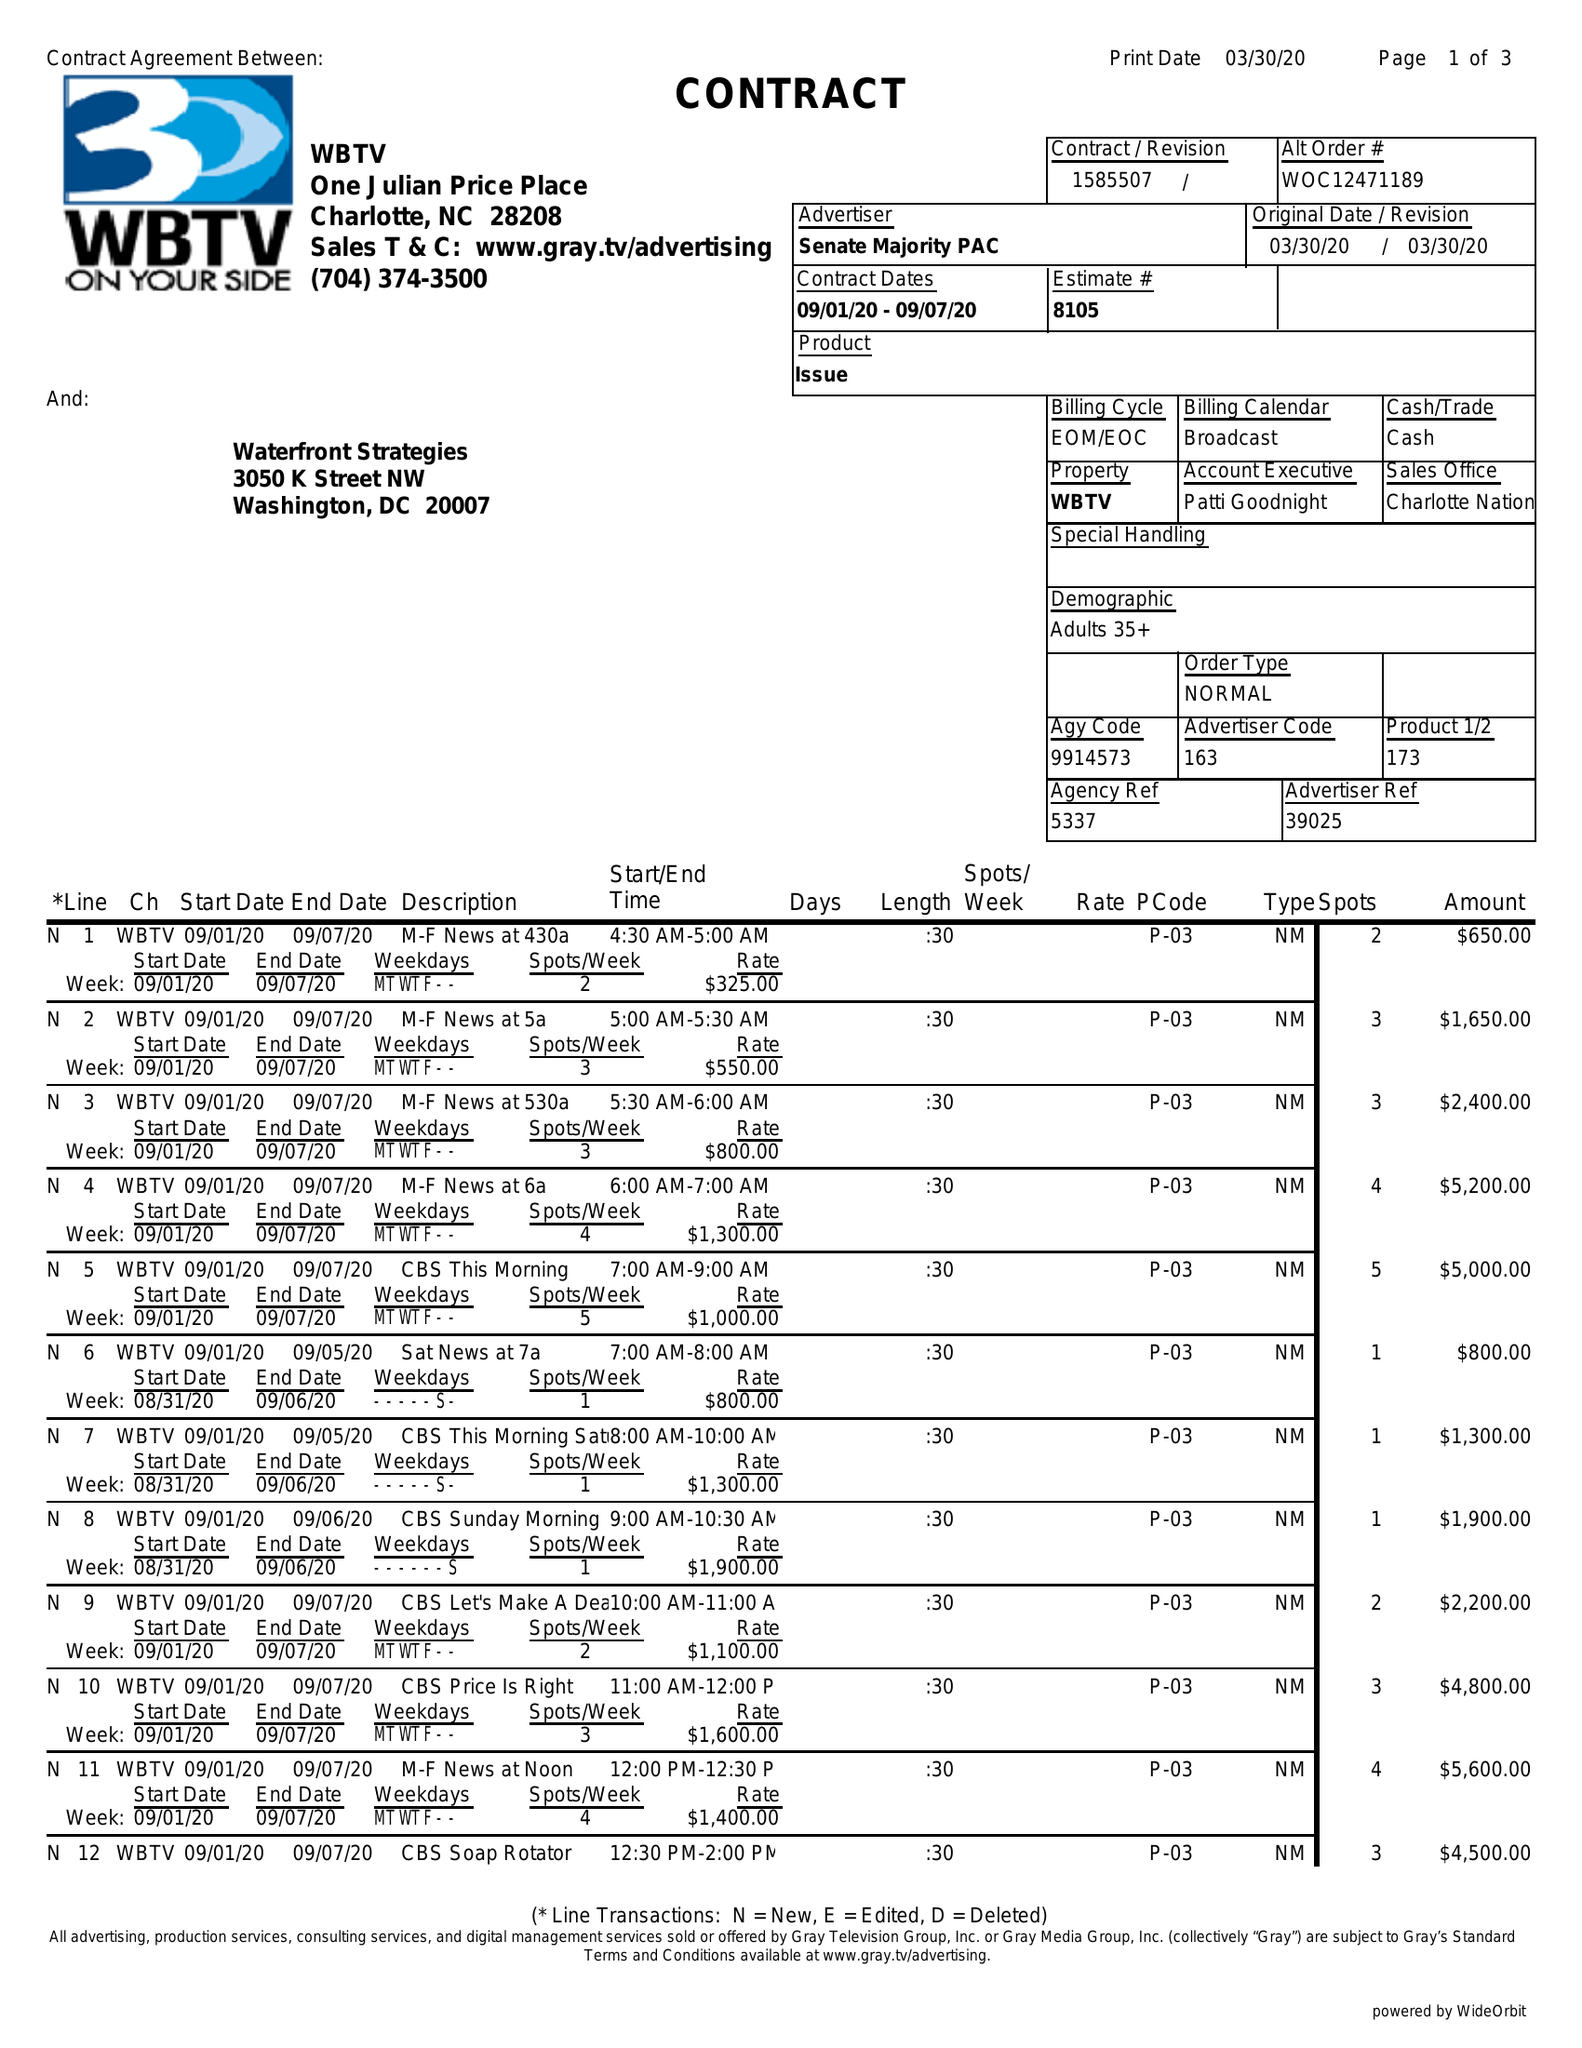What is the value for the advertiser?
Answer the question using a single word or phrase. SENATE MAJORITY PAC 